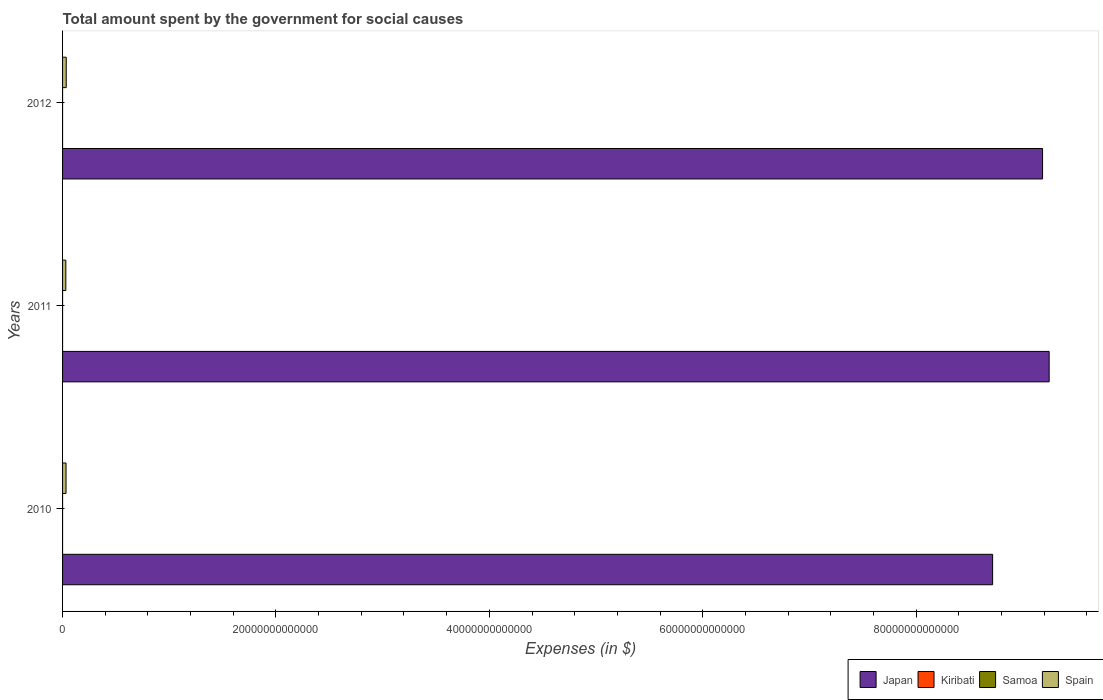How many different coloured bars are there?
Your answer should be compact. 4. How many groups of bars are there?
Offer a very short reply. 3. Are the number of bars on each tick of the Y-axis equal?
Your response must be concise. Yes. How many bars are there on the 1st tick from the top?
Offer a very short reply. 4. In how many cases, is the number of bars for a given year not equal to the number of legend labels?
Offer a terse response. 0. What is the amount spent for social causes by the government in Kiribati in 2011?
Offer a terse response. 1.17e+08. Across all years, what is the maximum amount spent for social causes by the government in Kiribati?
Offer a terse response. 1.17e+08. Across all years, what is the minimum amount spent for social causes by the government in Spain?
Provide a short and direct response. 3.07e+11. In which year was the amount spent for social causes by the government in Samoa maximum?
Give a very brief answer. 2012. In which year was the amount spent for social causes by the government in Kiribati minimum?
Your answer should be compact. 2010. What is the total amount spent for social causes by the government in Kiribati in the graph?
Give a very brief answer. 3.17e+08. What is the difference between the amount spent for social causes by the government in Japan in 2011 and that in 2012?
Your response must be concise. 6.18e+11. What is the difference between the amount spent for social causes by the government in Samoa in 2011 and the amount spent for social causes by the government in Japan in 2012?
Your answer should be very brief. -9.19e+13. What is the average amount spent for social causes by the government in Samoa per year?
Provide a short and direct response. 4.46e+05. In the year 2012, what is the difference between the amount spent for social causes by the government in Kiribati and amount spent for social causes by the government in Samoa?
Give a very brief answer. 1.05e+08. What is the ratio of the amount spent for social causes by the government in Kiribati in 2011 to that in 2012?
Offer a terse response. 1.11. Is the difference between the amount spent for social causes by the government in Kiribati in 2010 and 2011 greater than the difference between the amount spent for social causes by the government in Samoa in 2010 and 2011?
Your answer should be very brief. No. What is the difference between the highest and the second highest amount spent for social causes by the government in Kiribati?
Ensure brevity in your answer.  1.16e+07. What is the difference between the highest and the lowest amount spent for social causes by the government in Spain?
Provide a succinct answer. 3.75e+1. Is it the case that in every year, the sum of the amount spent for social causes by the government in Japan and amount spent for social causes by the government in Spain is greater than the sum of amount spent for social causes by the government in Kiribati and amount spent for social causes by the government in Samoa?
Keep it short and to the point. Yes. What does the 2nd bar from the top in 2012 represents?
Keep it short and to the point. Samoa. Is it the case that in every year, the sum of the amount spent for social causes by the government in Spain and amount spent for social causes by the government in Kiribati is greater than the amount spent for social causes by the government in Samoa?
Offer a terse response. Yes. How many bars are there?
Your response must be concise. 12. Are all the bars in the graph horizontal?
Give a very brief answer. Yes. What is the difference between two consecutive major ticks on the X-axis?
Ensure brevity in your answer.  2.00e+13. Are the values on the major ticks of X-axis written in scientific E-notation?
Offer a terse response. No. Does the graph contain any zero values?
Offer a very short reply. No. Where does the legend appear in the graph?
Provide a succinct answer. Bottom right. How many legend labels are there?
Offer a very short reply. 4. What is the title of the graph?
Provide a short and direct response. Total amount spent by the government for social causes. Does "India" appear as one of the legend labels in the graph?
Your response must be concise. No. What is the label or title of the X-axis?
Your response must be concise. Expenses (in $). What is the label or title of the Y-axis?
Provide a succinct answer. Years. What is the Expenses (in $) of Japan in 2010?
Ensure brevity in your answer.  8.72e+13. What is the Expenses (in $) of Kiribati in 2010?
Your response must be concise. 9.50e+07. What is the Expenses (in $) of Samoa in 2010?
Your answer should be very brief. 4.32e+05. What is the Expenses (in $) in Spain in 2010?
Your answer should be compact. 3.25e+11. What is the Expenses (in $) in Japan in 2011?
Your answer should be very brief. 9.25e+13. What is the Expenses (in $) of Kiribati in 2011?
Offer a terse response. 1.17e+08. What is the Expenses (in $) of Samoa in 2011?
Offer a terse response. 4.53e+05. What is the Expenses (in $) in Spain in 2011?
Your answer should be very brief. 3.07e+11. What is the Expenses (in $) in Japan in 2012?
Make the answer very short. 9.19e+13. What is the Expenses (in $) in Kiribati in 2012?
Give a very brief answer. 1.05e+08. What is the Expenses (in $) in Samoa in 2012?
Your answer should be compact. 4.53e+05. What is the Expenses (in $) in Spain in 2012?
Your answer should be compact. 3.44e+11. Across all years, what is the maximum Expenses (in $) in Japan?
Make the answer very short. 9.25e+13. Across all years, what is the maximum Expenses (in $) in Kiribati?
Give a very brief answer. 1.17e+08. Across all years, what is the maximum Expenses (in $) of Samoa?
Offer a very short reply. 4.53e+05. Across all years, what is the maximum Expenses (in $) of Spain?
Provide a short and direct response. 3.44e+11. Across all years, what is the minimum Expenses (in $) in Japan?
Provide a short and direct response. 8.72e+13. Across all years, what is the minimum Expenses (in $) of Kiribati?
Keep it short and to the point. 9.50e+07. Across all years, what is the minimum Expenses (in $) in Samoa?
Ensure brevity in your answer.  4.32e+05. Across all years, what is the minimum Expenses (in $) of Spain?
Your answer should be very brief. 3.07e+11. What is the total Expenses (in $) of Japan in the graph?
Provide a succinct answer. 2.71e+14. What is the total Expenses (in $) of Kiribati in the graph?
Your answer should be very brief. 3.17e+08. What is the total Expenses (in $) in Samoa in the graph?
Your answer should be very brief. 1.34e+06. What is the total Expenses (in $) of Spain in the graph?
Your answer should be compact. 9.76e+11. What is the difference between the Expenses (in $) in Japan in 2010 and that in 2011?
Give a very brief answer. -5.30e+12. What is the difference between the Expenses (in $) in Kiribati in 2010 and that in 2011?
Offer a terse response. -2.20e+07. What is the difference between the Expenses (in $) of Samoa in 2010 and that in 2011?
Offer a terse response. -2.12e+04. What is the difference between the Expenses (in $) in Spain in 2010 and that in 2011?
Provide a short and direct response. 1.84e+1. What is the difference between the Expenses (in $) of Japan in 2010 and that in 2012?
Your response must be concise. -4.68e+12. What is the difference between the Expenses (in $) in Kiribati in 2010 and that in 2012?
Your response must be concise. -1.04e+07. What is the difference between the Expenses (in $) in Samoa in 2010 and that in 2012?
Your response must be concise. -2.12e+04. What is the difference between the Expenses (in $) of Spain in 2010 and that in 2012?
Provide a short and direct response. -1.91e+1. What is the difference between the Expenses (in $) of Japan in 2011 and that in 2012?
Offer a terse response. 6.18e+11. What is the difference between the Expenses (in $) of Kiribati in 2011 and that in 2012?
Offer a terse response. 1.16e+07. What is the difference between the Expenses (in $) of Samoa in 2011 and that in 2012?
Make the answer very short. -5.38. What is the difference between the Expenses (in $) in Spain in 2011 and that in 2012?
Provide a short and direct response. -3.75e+1. What is the difference between the Expenses (in $) of Japan in 2010 and the Expenses (in $) of Kiribati in 2011?
Your response must be concise. 8.72e+13. What is the difference between the Expenses (in $) of Japan in 2010 and the Expenses (in $) of Samoa in 2011?
Provide a succinct answer. 8.72e+13. What is the difference between the Expenses (in $) of Japan in 2010 and the Expenses (in $) of Spain in 2011?
Ensure brevity in your answer.  8.69e+13. What is the difference between the Expenses (in $) in Kiribati in 2010 and the Expenses (in $) in Samoa in 2011?
Offer a terse response. 9.46e+07. What is the difference between the Expenses (in $) of Kiribati in 2010 and the Expenses (in $) of Spain in 2011?
Ensure brevity in your answer.  -3.07e+11. What is the difference between the Expenses (in $) of Samoa in 2010 and the Expenses (in $) of Spain in 2011?
Make the answer very short. -3.07e+11. What is the difference between the Expenses (in $) of Japan in 2010 and the Expenses (in $) of Kiribati in 2012?
Offer a terse response. 8.72e+13. What is the difference between the Expenses (in $) in Japan in 2010 and the Expenses (in $) in Samoa in 2012?
Provide a succinct answer. 8.72e+13. What is the difference between the Expenses (in $) in Japan in 2010 and the Expenses (in $) in Spain in 2012?
Keep it short and to the point. 8.68e+13. What is the difference between the Expenses (in $) of Kiribati in 2010 and the Expenses (in $) of Samoa in 2012?
Provide a short and direct response. 9.46e+07. What is the difference between the Expenses (in $) in Kiribati in 2010 and the Expenses (in $) in Spain in 2012?
Provide a succinct answer. -3.44e+11. What is the difference between the Expenses (in $) of Samoa in 2010 and the Expenses (in $) of Spain in 2012?
Give a very brief answer. -3.44e+11. What is the difference between the Expenses (in $) of Japan in 2011 and the Expenses (in $) of Kiribati in 2012?
Provide a short and direct response. 9.25e+13. What is the difference between the Expenses (in $) in Japan in 2011 and the Expenses (in $) in Samoa in 2012?
Provide a short and direct response. 9.25e+13. What is the difference between the Expenses (in $) of Japan in 2011 and the Expenses (in $) of Spain in 2012?
Offer a very short reply. 9.21e+13. What is the difference between the Expenses (in $) in Kiribati in 2011 and the Expenses (in $) in Samoa in 2012?
Provide a short and direct response. 1.17e+08. What is the difference between the Expenses (in $) of Kiribati in 2011 and the Expenses (in $) of Spain in 2012?
Provide a succinct answer. -3.44e+11. What is the difference between the Expenses (in $) of Samoa in 2011 and the Expenses (in $) of Spain in 2012?
Your response must be concise. -3.44e+11. What is the average Expenses (in $) in Japan per year?
Provide a succinct answer. 9.05e+13. What is the average Expenses (in $) of Kiribati per year?
Give a very brief answer. 1.06e+08. What is the average Expenses (in $) of Samoa per year?
Give a very brief answer. 4.46e+05. What is the average Expenses (in $) in Spain per year?
Your response must be concise. 3.25e+11. In the year 2010, what is the difference between the Expenses (in $) of Japan and Expenses (in $) of Kiribati?
Offer a terse response. 8.72e+13. In the year 2010, what is the difference between the Expenses (in $) of Japan and Expenses (in $) of Samoa?
Offer a terse response. 8.72e+13. In the year 2010, what is the difference between the Expenses (in $) of Japan and Expenses (in $) of Spain?
Provide a short and direct response. 8.68e+13. In the year 2010, what is the difference between the Expenses (in $) in Kiribati and Expenses (in $) in Samoa?
Ensure brevity in your answer.  9.46e+07. In the year 2010, what is the difference between the Expenses (in $) of Kiribati and Expenses (in $) of Spain?
Keep it short and to the point. -3.25e+11. In the year 2010, what is the difference between the Expenses (in $) in Samoa and Expenses (in $) in Spain?
Offer a very short reply. -3.25e+11. In the year 2011, what is the difference between the Expenses (in $) of Japan and Expenses (in $) of Kiribati?
Your answer should be compact. 9.25e+13. In the year 2011, what is the difference between the Expenses (in $) of Japan and Expenses (in $) of Samoa?
Provide a short and direct response. 9.25e+13. In the year 2011, what is the difference between the Expenses (in $) of Japan and Expenses (in $) of Spain?
Provide a succinct answer. 9.22e+13. In the year 2011, what is the difference between the Expenses (in $) in Kiribati and Expenses (in $) in Samoa?
Offer a terse response. 1.17e+08. In the year 2011, what is the difference between the Expenses (in $) in Kiribati and Expenses (in $) in Spain?
Make the answer very short. -3.06e+11. In the year 2011, what is the difference between the Expenses (in $) in Samoa and Expenses (in $) in Spain?
Make the answer very short. -3.07e+11. In the year 2012, what is the difference between the Expenses (in $) in Japan and Expenses (in $) in Kiribati?
Make the answer very short. 9.19e+13. In the year 2012, what is the difference between the Expenses (in $) in Japan and Expenses (in $) in Samoa?
Provide a succinct answer. 9.19e+13. In the year 2012, what is the difference between the Expenses (in $) of Japan and Expenses (in $) of Spain?
Give a very brief answer. 9.15e+13. In the year 2012, what is the difference between the Expenses (in $) in Kiribati and Expenses (in $) in Samoa?
Provide a succinct answer. 1.05e+08. In the year 2012, what is the difference between the Expenses (in $) of Kiribati and Expenses (in $) of Spain?
Your response must be concise. -3.44e+11. In the year 2012, what is the difference between the Expenses (in $) in Samoa and Expenses (in $) in Spain?
Your answer should be very brief. -3.44e+11. What is the ratio of the Expenses (in $) of Japan in 2010 to that in 2011?
Your answer should be very brief. 0.94. What is the ratio of the Expenses (in $) in Kiribati in 2010 to that in 2011?
Ensure brevity in your answer.  0.81. What is the ratio of the Expenses (in $) of Samoa in 2010 to that in 2011?
Give a very brief answer. 0.95. What is the ratio of the Expenses (in $) of Spain in 2010 to that in 2011?
Provide a short and direct response. 1.06. What is the ratio of the Expenses (in $) in Japan in 2010 to that in 2012?
Keep it short and to the point. 0.95. What is the ratio of the Expenses (in $) in Kiribati in 2010 to that in 2012?
Give a very brief answer. 0.9. What is the ratio of the Expenses (in $) in Samoa in 2010 to that in 2012?
Ensure brevity in your answer.  0.95. What is the ratio of the Expenses (in $) of Spain in 2010 to that in 2012?
Give a very brief answer. 0.94. What is the ratio of the Expenses (in $) in Japan in 2011 to that in 2012?
Give a very brief answer. 1.01. What is the ratio of the Expenses (in $) of Kiribati in 2011 to that in 2012?
Provide a succinct answer. 1.11. What is the ratio of the Expenses (in $) of Samoa in 2011 to that in 2012?
Provide a short and direct response. 1. What is the ratio of the Expenses (in $) in Spain in 2011 to that in 2012?
Give a very brief answer. 0.89. What is the difference between the highest and the second highest Expenses (in $) of Japan?
Give a very brief answer. 6.18e+11. What is the difference between the highest and the second highest Expenses (in $) of Kiribati?
Provide a succinct answer. 1.16e+07. What is the difference between the highest and the second highest Expenses (in $) in Samoa?
Keep it short and to the point. 5.38. What is the difference between the highest and the second highest Expenses (in $) of Spain?
Provide a succinct answer. 1.91e+1. What is the difference between the highest and the lowest Expenses (in $) of Japan?
Provide a succinct answer. 5.30e+12. What is the difference between the highest and the lowest Expenses (in $) of Kiribati?
Your answer should be compact. 2.20e+07. What is the difference between the highest and the lowest Expenses (in $) of Samoa?
Offer a very short reply. 2.12e+04. What is the difference between the highest and the lowest Expenses (in $) in Spain?
Ensure brevity in your answer.  3.75e+1. 